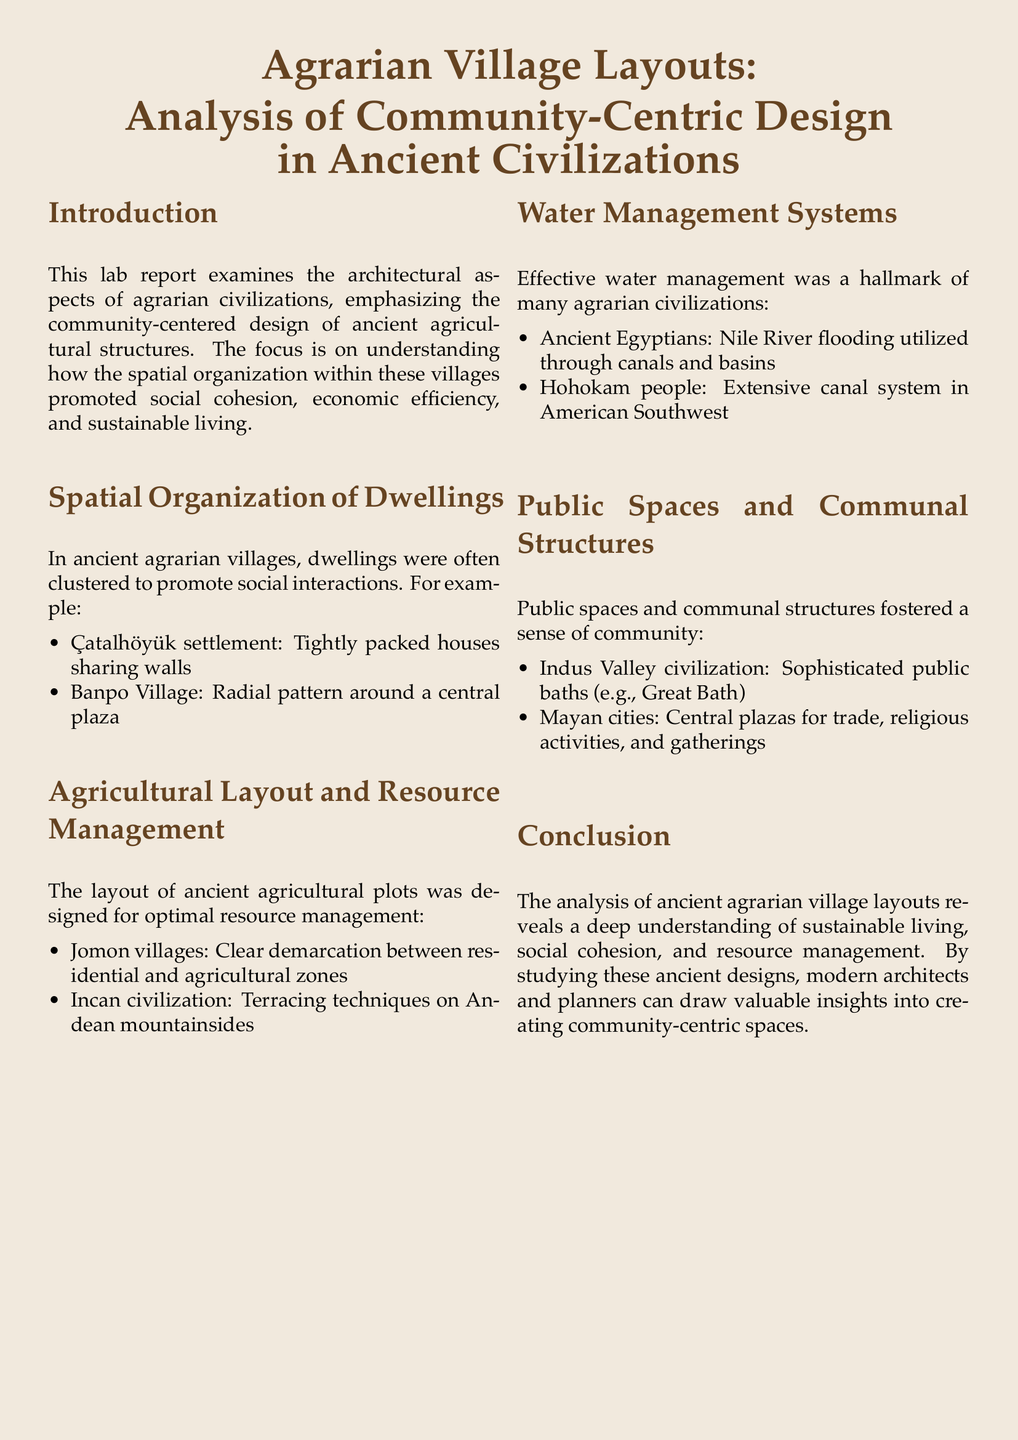What is the focus of the lab report? The lab report focuses on understanding how spatial organization within agrarian villages promoted social cohesion, economic efficiency, and sustainable living.
Answer: community-centered design Which ancient settlement had tightly packed houses? The report mentions Çatalhöyük as a settlement with tightly packed houses sharing walls.
Answer: Çatalhöyük What agricultural technique is associated with the Incan civilization? The report highlights terracing techniques on Andean mountainsides as a characteristic of Incan agricultural layout.
Answer: Terracing techniques What type of system did the Hohokam people develop? The report describes the extensive canal system in the American Southwest as a hallmark of the Hohokam people's water management.
Answer: canal system Which civilization is noted for having sophisticated public baths? The Indus Valley civilization is mentioned in relation to its sophisticated public baths, specifically the Great Bath.
Answer: Indus Valley civilization What is stated about public spaces in Mayan cities? The report emphasizes that Central plazas in Mayan cities were used for trade, religious activities, and gatherings.
Answer: Central plazas What is the significance of the Nile River in ancient Egypt? It was utilized through canals and basins, effectively managing water through flooding.
Answer: canals and basins What is the conclusion regarding ancient village layouts? The report concludes that ancient designs provide valuable insights into creating community-centric spaces.
Answer: sustainable living 